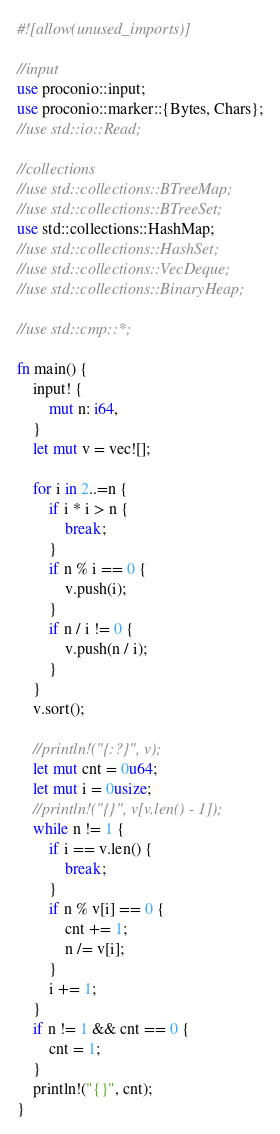Convert code to text. <code><loc_0><loc_0><loc_500><loc_500><_Rust_>#![allow(unused_imports)]

//input
use proconio::input;
use proconio::marker::{Bytes, Chars};
//use std::io::Read;

//collections
//use std::collections::BTreeMap;
//use std::collections::BTreeSet;
use std::collections::HashMap;
//use std::collections::HashSet;
//use std::collections::VecDeque;
//use std::collections::BinaryHeap;

//use std::cmp::*;

fn main() {
    input! {
        mut n: i64,
    }
    let mut v = vec![];

    for i in 2..=n {
        if i * i > n {
            break;
        }
        if n % i == 0 {
            v.push(i);
        }
        if n / i != 0 {
            v.push(n / i);
        }
    }
    v.sort();

    //println!("{:?}", v);
    let mut cnt = 0u64;
    let mut i = 0usize;
    //println!("{}", v[v.len() - 1]);
    while n != 1 {
        if i == v.len() {
            break;
        }
        if n % v[i] == 0 {
            cnt += 1;
            n /= v[i];
        }
        i += 1;
    }
    if n != 1 && cnt == 0 {
        cnt = 1;
    }
    println!("{}", cnt);
}
</code> 